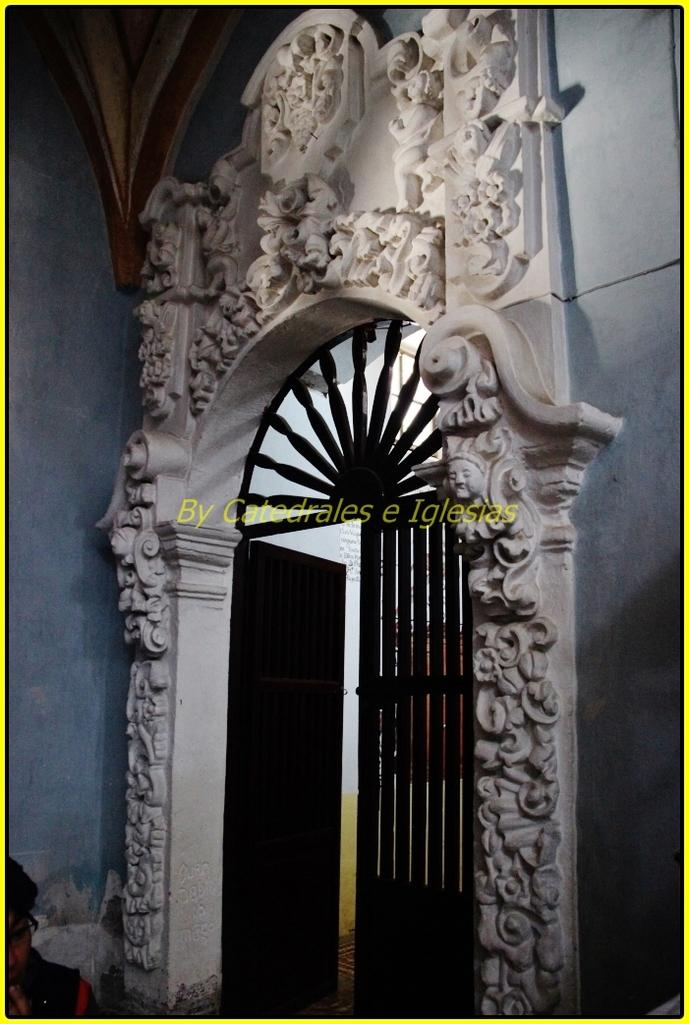What is the main object in the image? There is a fence gate in the image. Who or what is near the fence gate? There is a person in the image. How is the person dressed? The person is wearing clothes. What accessory is the person wearing? The person is wearing spectacles. What else can be seen in the background of the image? There is a wall in the image. Is there any indication that the image has been reproduced or altered? Yes, there is a watermark in the image. What type of seed is being planted in the office in the image? There is no seed or office present in the image; it features a fence gate, a person, and a wall. What time is indicated by the clock in the image? There is no clock present in the image. 